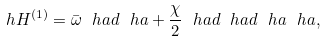<formula> <loc_0><loc_0><loc_500><loc_500>\ h H ^ { ( 1 ) } = \bar { \omega } \ h a d \ h a + \frac { \chi } { 2 } \ h a d \ h a d \ h a \ h a ,</formula> 